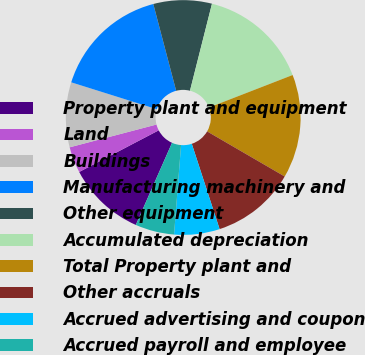<chart> <loc_0><loc_0><loc_500><loc_500><pie_chart><fcel>Property plant and equipment<fcel>Land<fcel>Buildings<fcel>Manufacturing machinery and<fcel>Other equipment<fcel>Accumulated depreciation<fcel>Total Property plant and<fcel>Other accruals<fcel>Accrued advertising and coupon<fcel>Accrued payroll and employee<nl><fcel>10.71%<fcel>3.59%<fcel>8.93%<fcel>16.05%<fcel>8.04%<fcel>15.16%<fcel>14.27%<fcel>11.6%<fcel>6.26%<fcel>5.37%<nl></chart> 